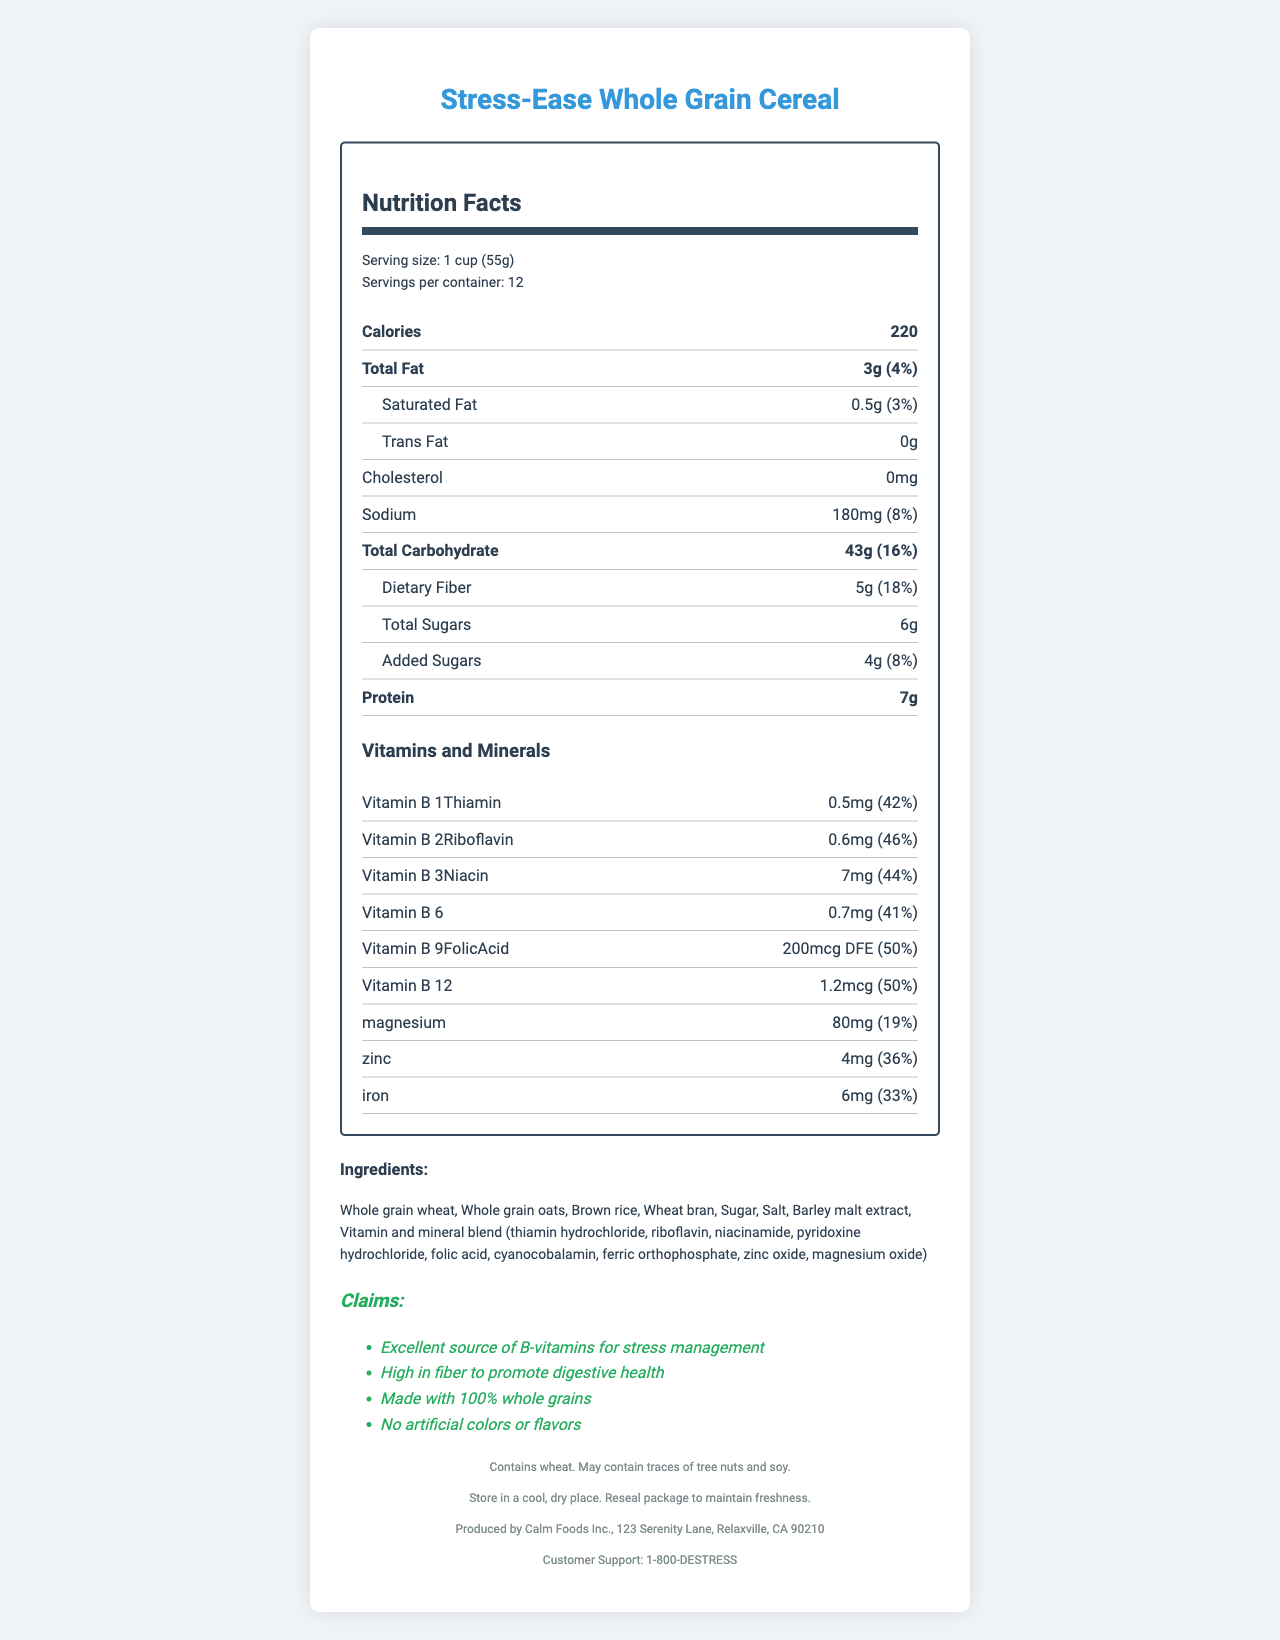what is the serving size? The serving size is clearly stated in the serving information section at the top of the document.
Answer: 1 cup (55g) how many calories are in one serving? The calorie content per serving is listed under the Calories section.
Answer: 220 what is the amount of Vitamin B6 per serving? The amount of Vitamin B6 is listed under the Vitamins and Minerals section as 0.7mg.
Answer: 0.7mg how much dietary fiber is in one serving? The dietary fiber content is mentioned under the Total Carbohydrate section as 5g.
Answer: 5g who is the manufacturer of this product? The manufacturer's information is located at the bottom of the document under the Manufacturer Info section.
Answer: Calm Foods Inc. which vitamin has the highest daily value percentage? 
A. Vitamin B1 (Thiamin) 
B. Vitamin B2 (Riboflavin) 
C. Vitamin B9 (Folic Acid) 
D. Vitamin B12 Vitamin B9 (Folic Acid) has a daily value of 50%, the highest among the listed options.
Answer: C. Vitamin B9 (Folic Acid) what is the amount of added sugars per serving? 
1. 4g 
2. 6g 
3. 8g 
4. 10g The document specifies that the added sugars content is 4g per serving.
Answer: 1. 4g does this cereal contain artificial colors or flavors? The claims section states that the product contains no artificial colors or flavors.
Answer: No briefly summarize the main nutritional benefits of this whole grain cereal. The summary covers the key nutritional benefits and highlights mentioned in the claims, vitamin, and mineral sections.
Answer: This cereal is an excellent source of B-vitamins for stress management, high in fiber to promote digestive health, and made with 100% whole grains. It has no artificial colors or flavors and contains essential minerals like magnesium and zinc. what are the daily value percentages for Vitamin B2 (Riboflavin) and Vitamin B3 (Niacin)? The daily value percentages for Vitamin B2 (Riboflavin) and Vitamin B3 (Niacin) are listed next to their amounts in the Vitamins and Minerals section.
Answer: 46% and 44%, respectively. where is this product manufactured? The address for the manufacturer is listed under the Manufacturer Info section at the bottom of the document.
Answer: 123 Serenity Lane, Relaxville, CA 90210 what is the customer support hotline number? The customer support hotline number is mentioned at the bottom of the document under Customer Support.
Answer: 1-800-DESTRESS is there any cholesterol in this cereal? Cholesterol is listed as 0mg in the nutrient row for Cholesterol.
Answer: No how many servings are there in one container? The number of servings per container is listed in the serving information section.
Answer: 12 what type of sweetener is used in this cereal? The ingredients section lists sugar and barley malt extract as the sweeteners used in the cereal.
Answer: Sugar and barley malt extract what is the purpose of the Vitamin and mineral blend mentioned in the ingredients? The document does not provide specific information about the purpose of the Vitamin and mineral blend; it only lists its components.
Answer: Cannot be determined 